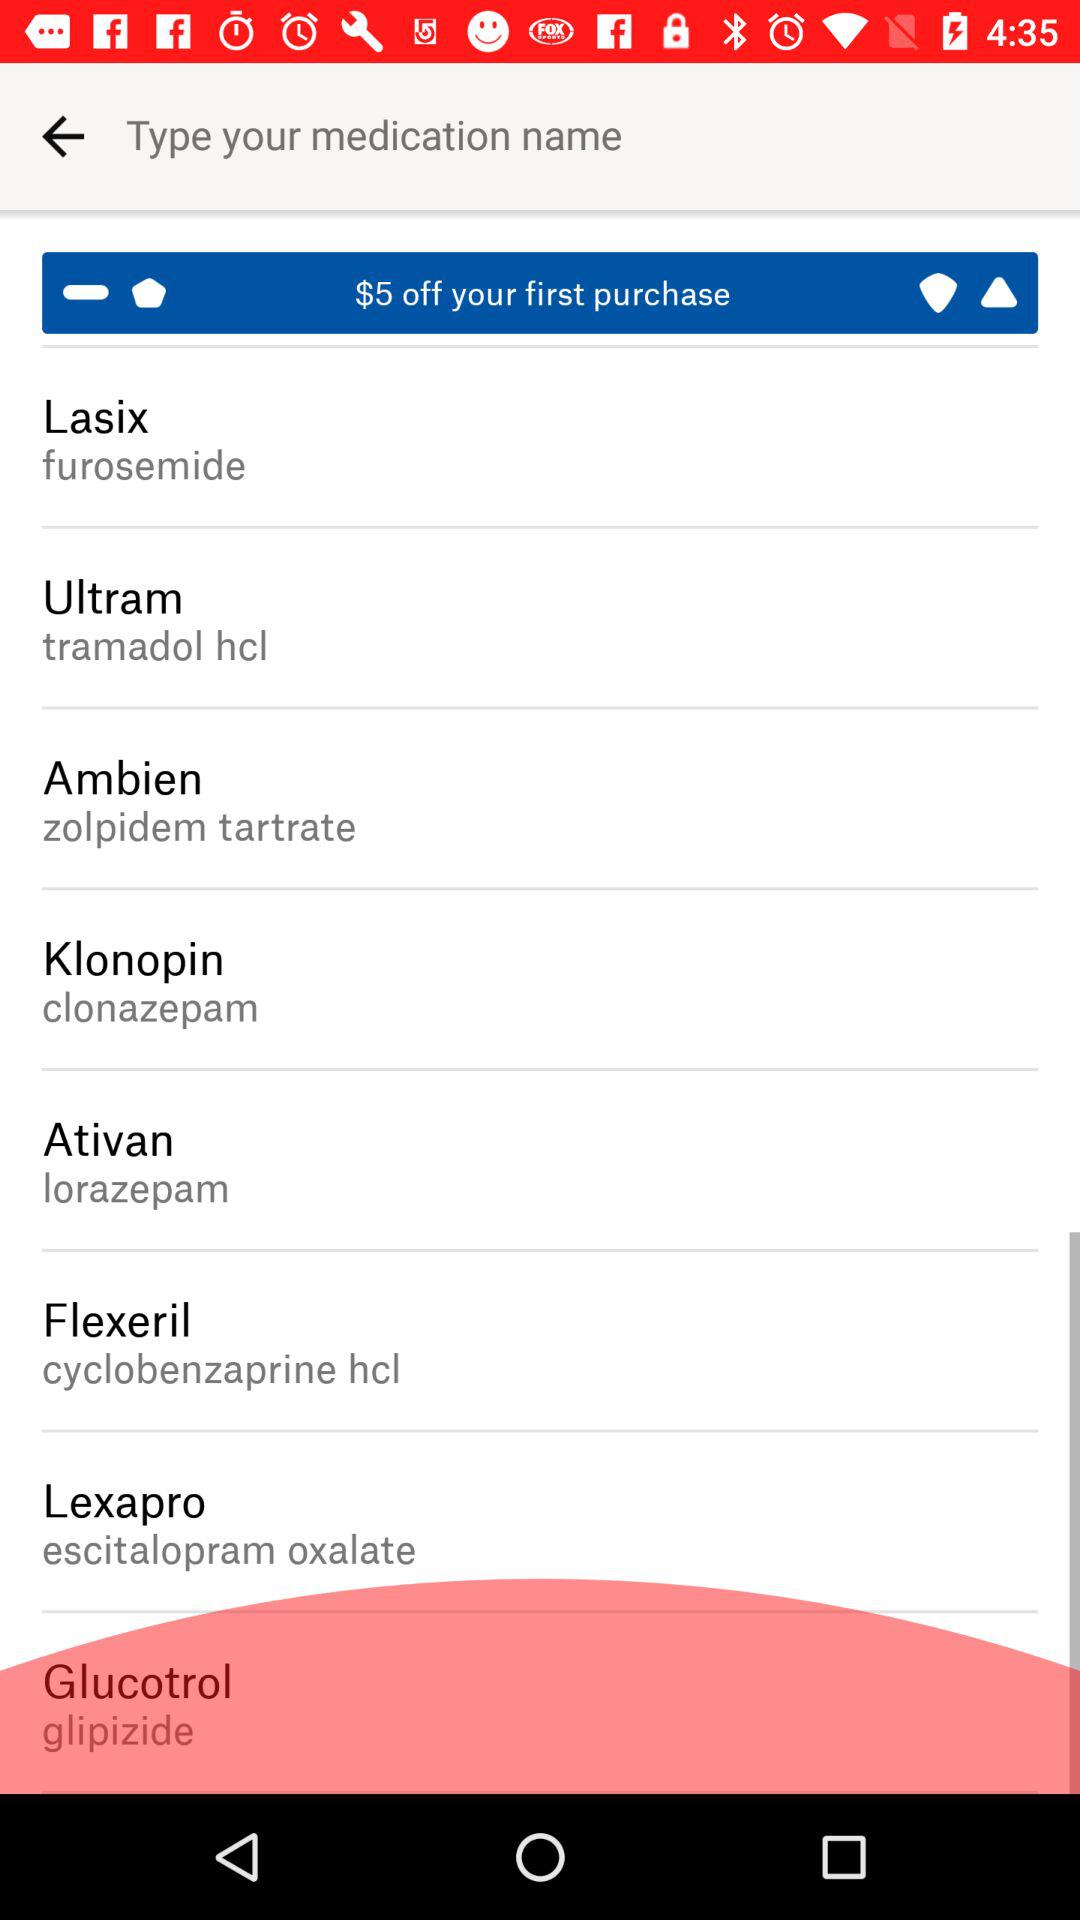What is the typed medication name?
When the provided information is insufficient, respond with <no answer>. <no answer> 